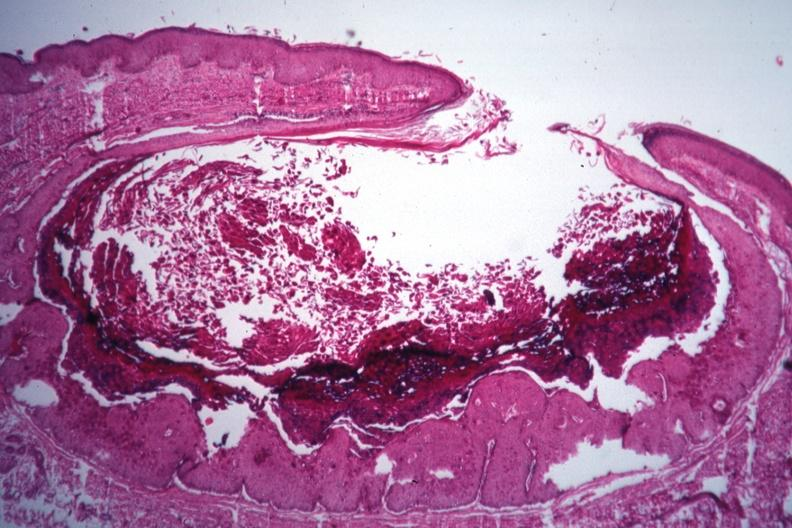s close-up of lesion present?
Answer the question using a single word or phrase. No 